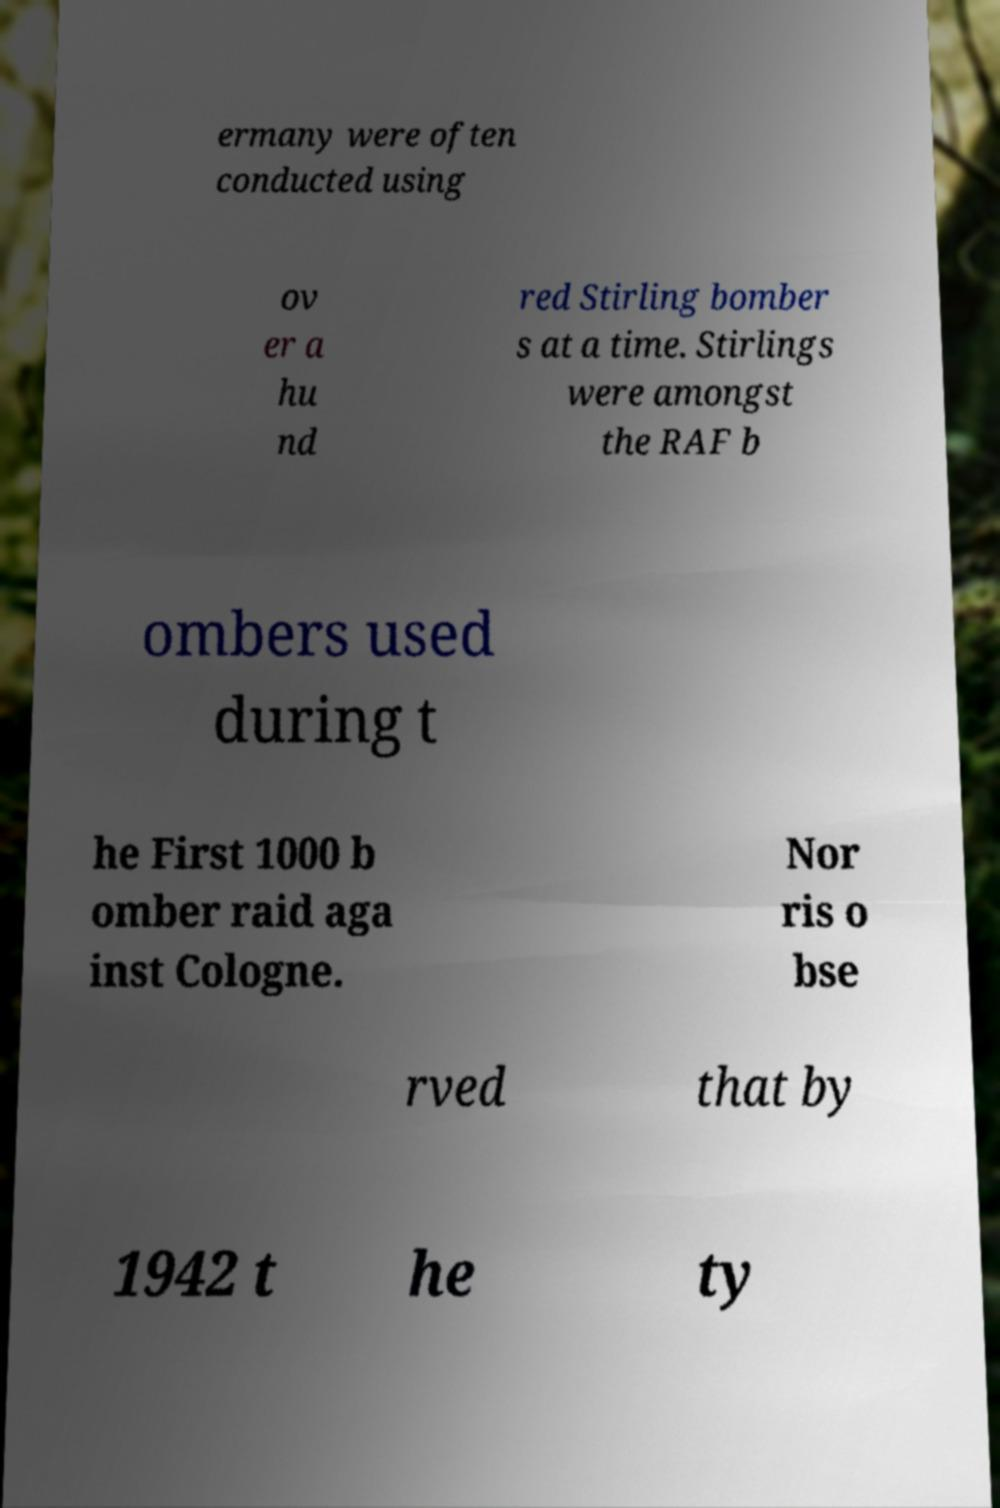Can you accurately transcribe the text from the provided image for me? ermany were often conducted using ov er a hu nd red Stirling bomber s at a time. Stirlings were amongst the RAF b ombers used during t he First 1000 b omber raid aga inst Cologne. Nor ris o bse rved that by 1942 t he ty 